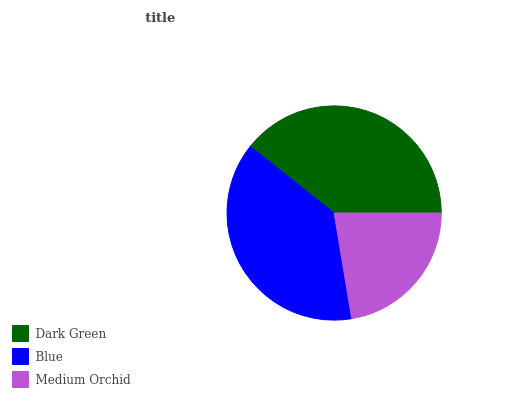Is Medium Orchid the minimum?
Answer yes or no. Yes. Is Dark Green the maximum?
Answer yes or no. Yes. Is Blue the minimum?
Answer yes or no. No. Is Blue the maximum?
Answer yes or no. No. Is Dark Green greater than Blue?
Answer yes or no. Yes. Is Blue less than Dark Green?
Answer yes or no. Yes. Is Blue greater than Dark Green?
Answer yes or no. No. Is Dark Green less than Blue?
Answer yes or no. No. Is Blue the high median?
Answer yes or no. Yes. Is Blue the low median?
Answer yes or no. Yes. Is Dark Green the high median?
Answer yes or no. No. Is Medium Orchid the low median?
Answer yes or no. No. 